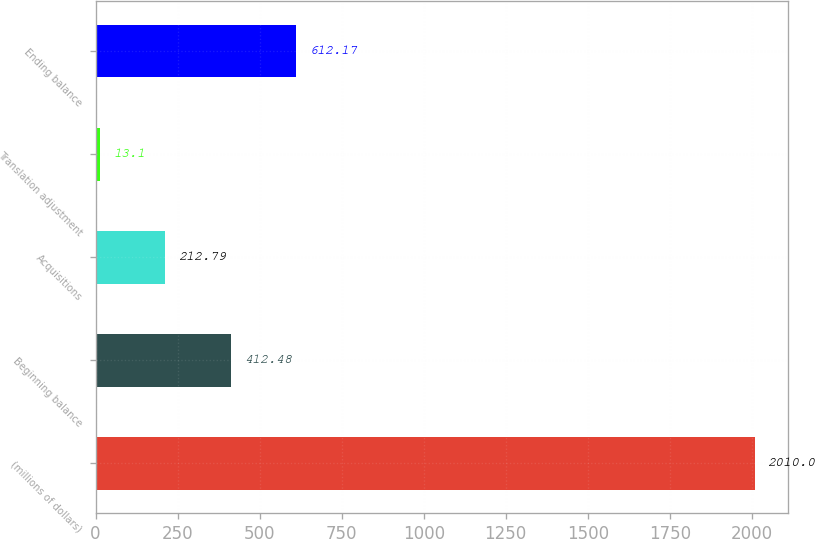Convert chart to OTSL. <chart><loc_0><loc_0><loc_500><loc_500><bar_chart><fcel>(millions of dollars)<fcel>Beginning balance<fcel>Acquisitions<fcel>Translation adjustment<fcel>Ending balance<nl><fcel>2010<fcel>412.48<fcel>212.79<fcel>13.1<fcel>612.17<nl></chart> 